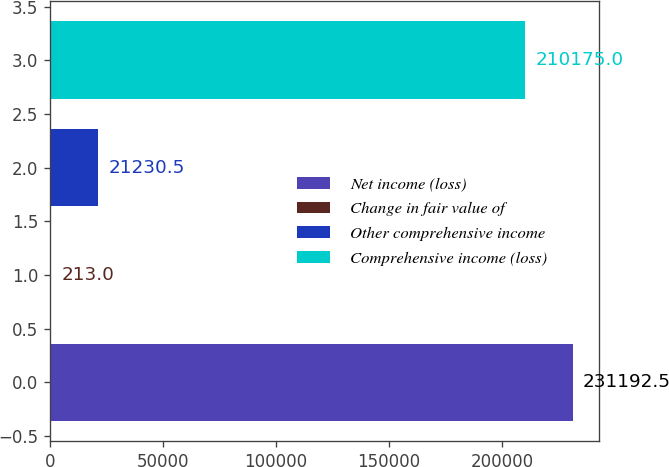<chart> <loc_0><loc_0><loc_500><loc_500><bar_chart><fcel>Net income (loss)<fcel>Change in fair value of<fcel>Other comprehensive income<fcel>Comprehensive income (loss)<nl><fcel>231192<fcel>213<fcel>21230.5<fcel>210175<nl></chart> 